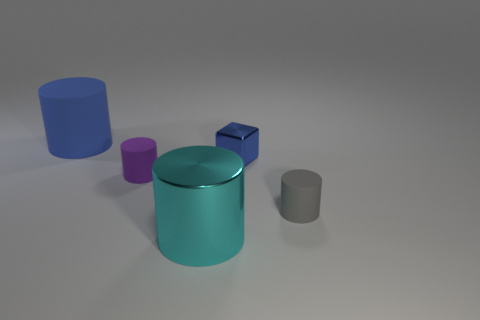Does the metal cube have the same color as the large matte cylinder?
Your answer should be very brief. Yes. Does the object to the left of the purple thing have the same color as the small metal block?
Your answer should be very brief. Yes. The purple cylinder is what size?
Provide a succinct answer. Small. There is a large metallic cylinder in front of the object to the left of the purple matte cylinder; are there any cylinders right of it?
Give a very brief answer. Yes. There is a cyan shiny cylinder; how many large cyan cylinders are on the right side of it?
Ensure brevity in your answer.  0. What number of small shiny objects have the same color as the large matte cylinder?
Your response must be concise. 1. How many things are either cylinders that are in front of the blue matte cylinder or cylinders on the right side of the large blue cylinder?
Offer a very short reply. 3. Is the number of purple matte things greater than the number of tiny yellow metallic blocks?
Offer a terse response. Yes. What color is the big cylinder that is to the right of the large blue rubber cylinder?
Give a very brief answer. Cyan. Is the shape of the big cyan metallic thing the same as the large blue rubber thing?
Make the answer very short. Yes. 